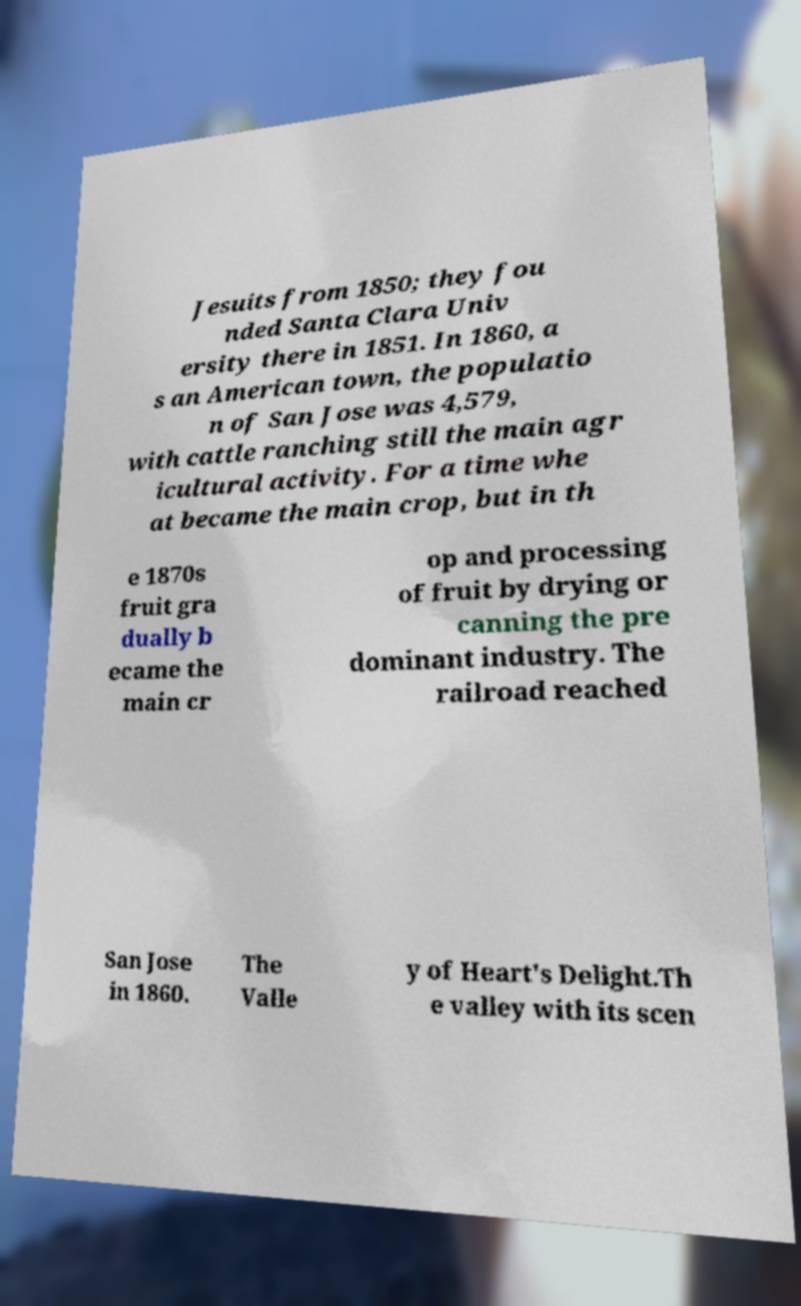I need the written content from this picture converted into text. Can you do that? Jesuits from 1850; they fou nded Santa Clara Univ ersity there in 1851. In 1860, a s an American town, the populatio n of San Jose was 4,579, with cattle ranching still the main agr icultural activity. For a time whe at became the main crop, but in th e 1870s fruit gra dually b ecame the main cr op and processing of fruit by drying or canning the pre dominant industry. The railroad reached San Jose in 1860. The Valle y of Heart's Delight.Th e valley with its scen 